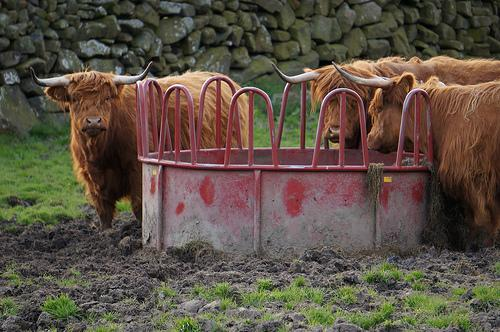Question: what are on these animal's heads?
Choices:
A. Hair.
B. Ears.
C. Horns.
D. Crowns.
Answer with the letter. Answer: C Question: why are the animals vertical?
Choices:
A. They're standing up.
B. They are jumping.
C. They are fighting.
D. They are hanging from the tree.
Answer with the letter. Answer: A Question: what are they doing?
Choices:
A. Eating.
B. Sleeping.
C. Running.
D. Dancing.
Answer with the letter. Answer: A Question: where was this picture taken?
Choices:
A. In the park.
B. By the lake.
C. On a boat.
D. Outside in the sun.
Answer with the letter. Answer: D Question: what color is the trough?
Choices:
A. Black.
B. White.
C. Blue and green.
D. Silver and red.
Answer with the letter. Answer: D 